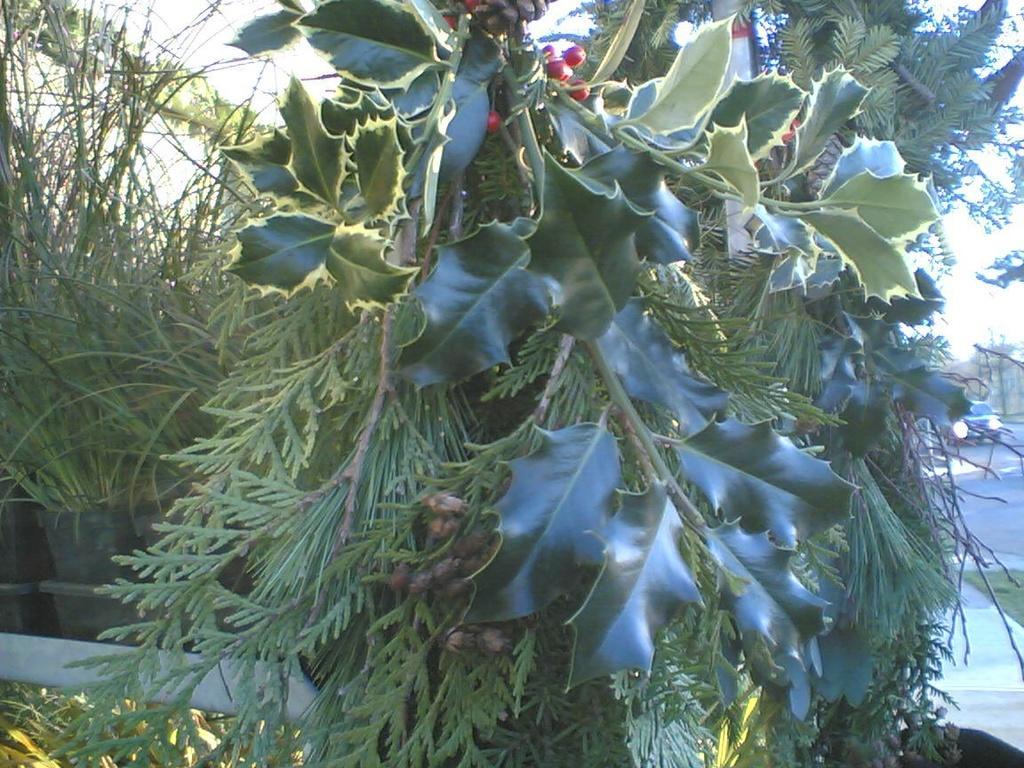Could you give a brief overview of what you see in this image? In this image I can see a tree which is green in color and to it I can see few fruits which are red and black in color. In the background I cam see the road, a car on the road, few trees and the sky. 